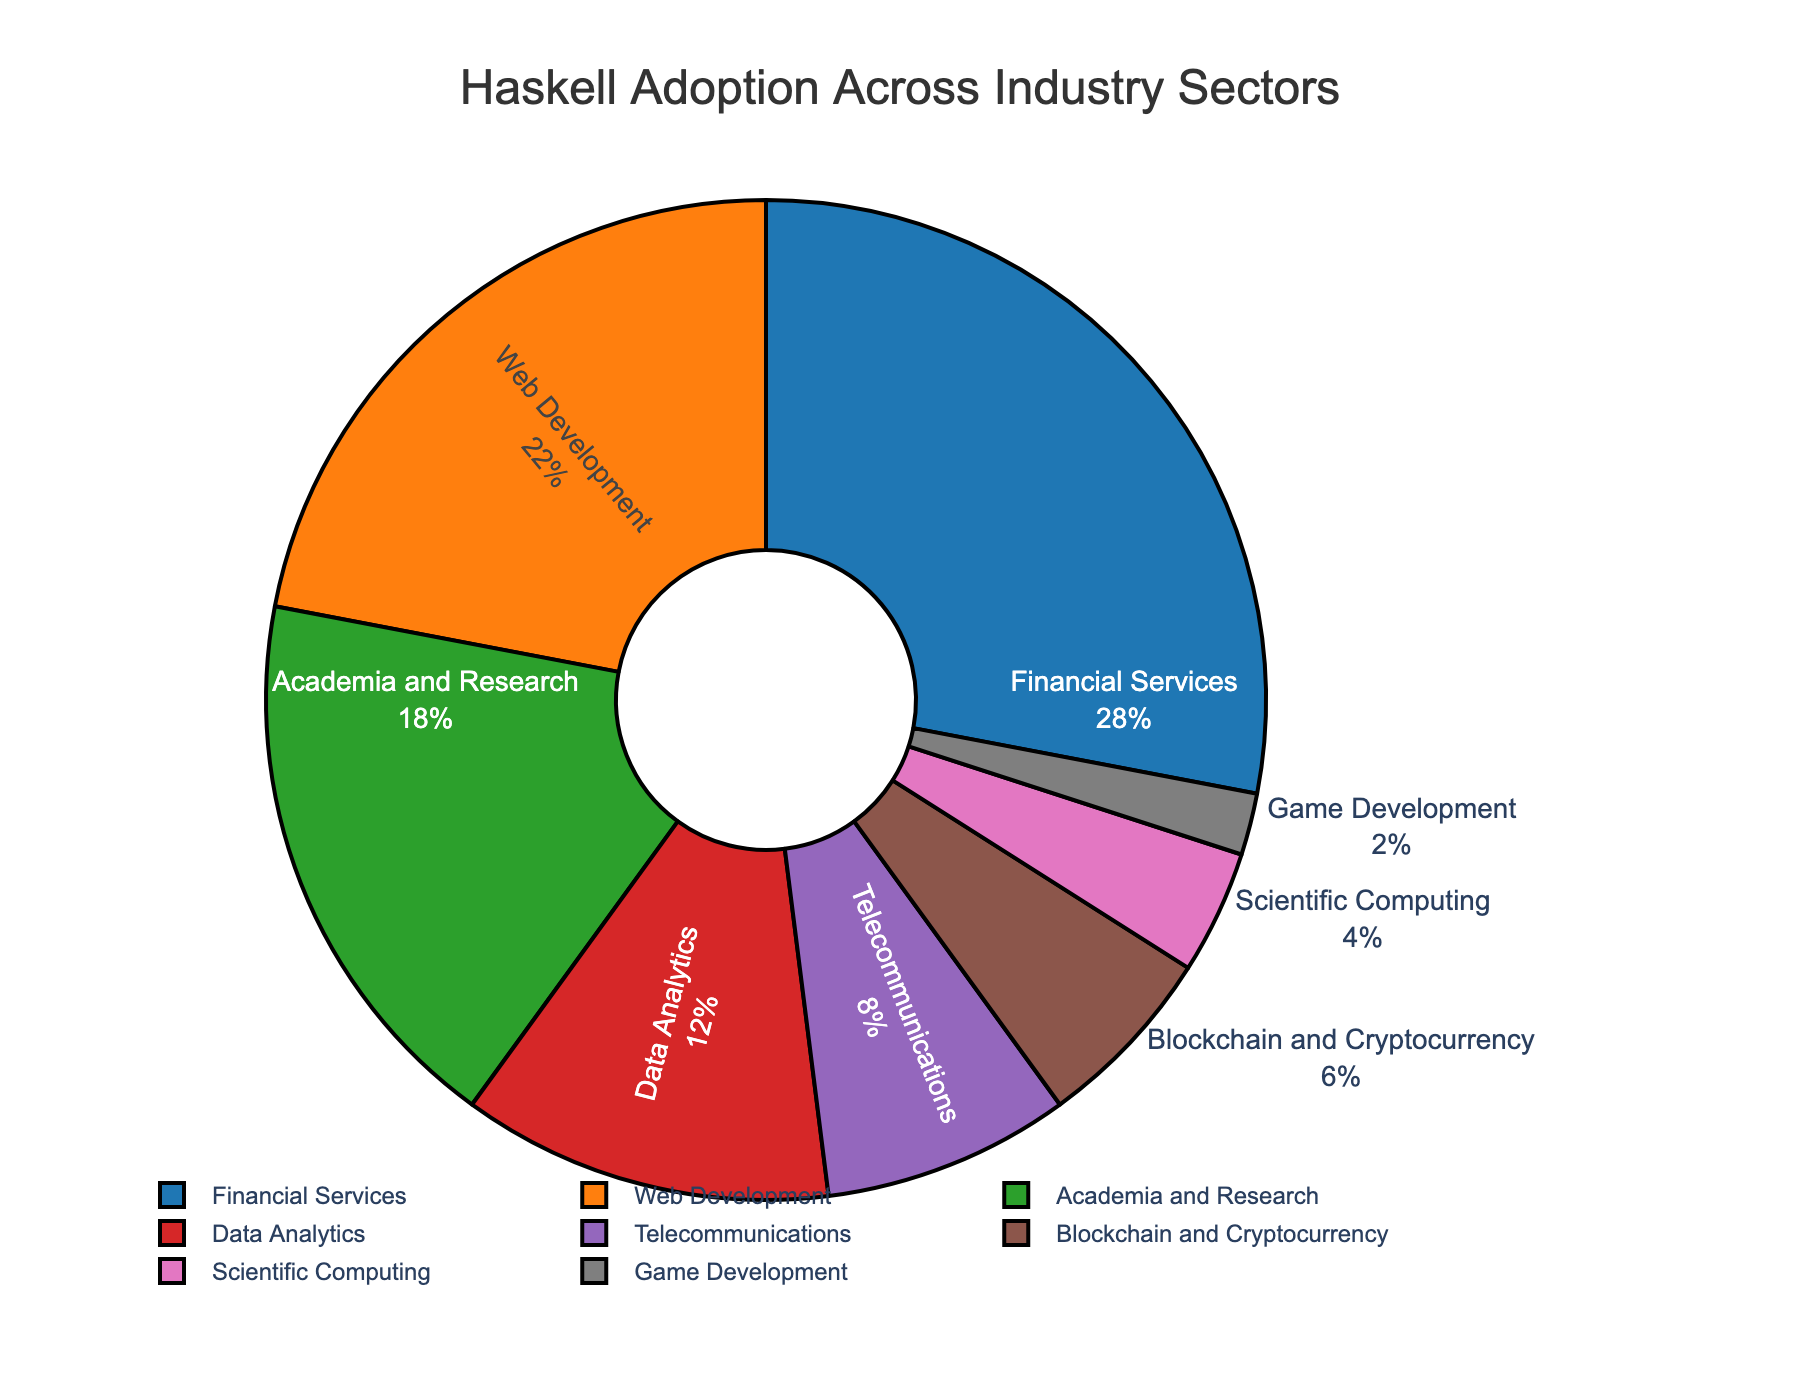What percentage of Haskell adoption is attributed to Financial Services and Data Analytics combined? To find the combined percentage, add the percentages of Financial Services (28%) and Data Analytics (12%): 28 + 12 = 40
Answer: 40% How do the percentages of Web Development and Academia and Research compare? Web Development accounts for 22% and Academia and Research accounts for 18%. Comparing these, Web Development has a higher percentage.
Answer: Web Development > Academia and Research Which industry sector has the lowest adoption of Haskell? The sector with the lowest adoption percentage is Game Development with 2% as seen from the chart.
Answer: Game Development Is the percentage of Haskell adoption in Telecommunications greater than the percentage in Blockchain and Cryptocurrency? Telecommunications has an adoption percentage of 8%, while Blockchain and Cryptocurrency has 6%. Therefore, Telecommunications has a greater percentage.
Answer: Yes What is the total percentage of Haskell adoption in sectors other than Financial Services and Web Development? Subtract the percentages of Financial Services (28%) and Web Development (22%) from 100%: 100 - 28 - 22 = 50
Answer: 50% What percentage of Haskell adoption do the two largest sectors (Financial Services and Web Development) together represent? Adding the percentages of Financial Services (28%) and Web Development (22%): 28 + 22 = 50
Answer: 50% What is the difference in the percentage of Haskell adoption between Data Analytics and Scientific Computing? Subtract the percentage of Scientific Computing (4%) from Data Analytics (12%): 12 - 4 = 8
Answer: 8% Which industries combined make up a larger percentage: Blockchain and Cryptocurrency plus Telecommunications, or Data Analytics alone? Adding Blockchain and Cryptocurrency (6%) and Telecommunications (8%) gives 14%. Data Analytics is 12%. Comparing these two, Blockchain and Cryptocurrency plus Telecommunications make up a larger percentage.
Answer: Blockchain and Cryptocurrency + Telecommunications What is the average percentage of Haskell adoption across all the sectors listed? Sum all the sector percentages and divide by the number of sectors: (28 + 22 + 18 + 12 + 8 + 6 + 4 + 2) / 8 = 100 / 8 = 12.5
Answer: 12.5% Which sector has the closest percentage of Haskell adoption to the average value across all sectors? The average adoption percentage is 12.5%. Data Analytics has a percentage of 12%, which is closest to the average.
Answer: Data Analytics 